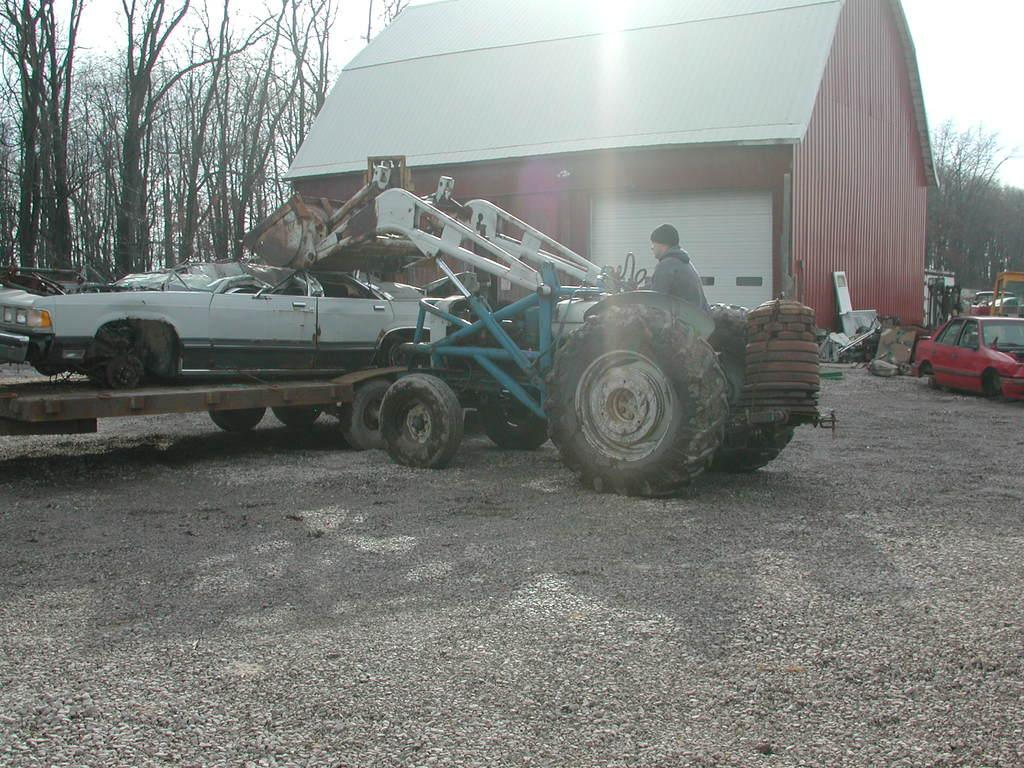What types of vehicles can be seen in the image? There are vehicles in the image, but the specific types are not mentioned. What is the person in the image doing? The person is sitting on a tractor. What structure is visible in the image? There is a house in the image. What type of vegetation is present in the image? There are trees in the image. What is visible at the top of the image? The sky is visible at the top of the image. Can you tell me how many marbles are scattered around the tractor in the image? There are no marbles present in the image; the person is sitting on a tractor, and there are vehicles, a house, trees, and the sky visible. What type of wren is perched on the roof of the house in the image? There is no wren present in the image; only vehicles, a person on a tractor, a house, trees, and the sky are visible. 